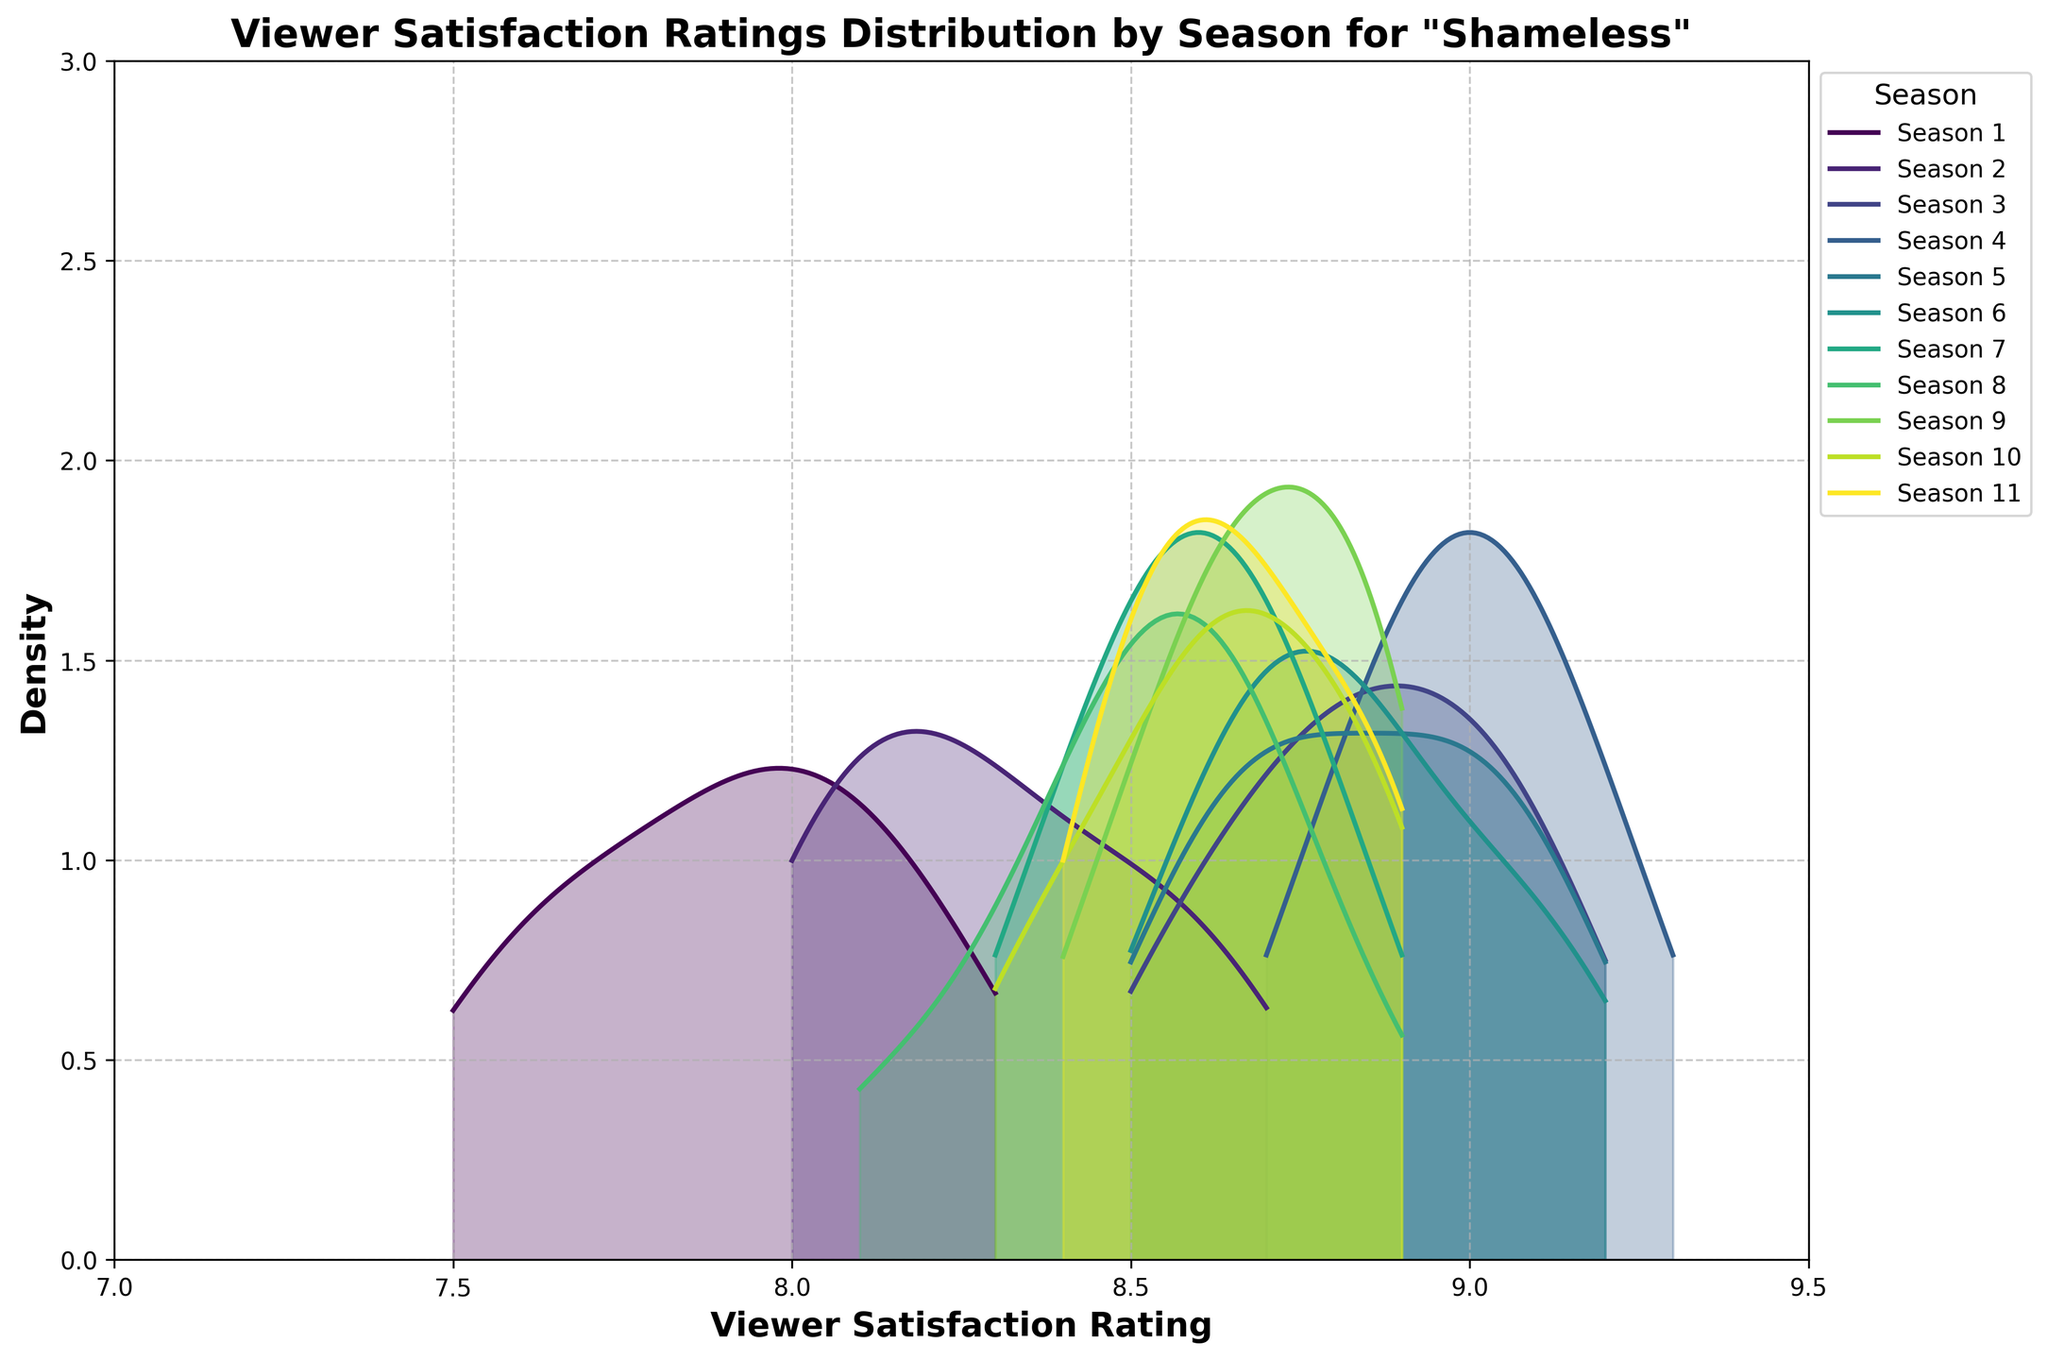Which season shows the highest peak in the density distribution? The highest peak in a density plot corresponds to the highest density of viewer satisfaction ratings. By visually inspecting the density curves, Season 3 shows the highest peak.
Answer: Season 3 What is the range of viewer satisfaction ratings plotted on the x-axis? The x-axis range is defined by the minimum and maximum viewer satisfaction ratings shown on the plot. The plot spans from 7 to 9.5.
Answer: 7 to 9.5 Which seasons have overlapping density curves around a rating of 8.9? To determine overlapping density curves at a rating of 8.9, examine the curves visually at this x-axis value. Seasons 6, 8, 9, 10, and 11 have densities around this point.
Answer: Seasons 6, 8, 9, 10, and 11 Are there any seasons where the viewer satisfaction ratings are more spread out compared to others? Spread out ratings are indicated by wider density curves. Season 1 shows a wider spread compared to the more peaked distributions of other seasons.
Answer: Season 1 Which season has the narrowest concentration of viewer satisfaction ratings? A narrow concentration is indicated by a sharp, peaked density curve. Season 3 shows the narrowest concentration with a sharp peak around 9.0.
Answer: Season 3 How does the density distribution of Season 7 compare to that of Season 11 around the rating of 8.7? Comparing the density values visually around 8.7, both seasons have a density curve passing through 8.7, but Season 7 appears slightly broader whereas Season 11 seems more concentrated.
Answer: Season 7 is broader, Season 11 is more concentrated Identify a season with a bimodal distribution, if any. A bimodal distribution would have two peaks in its density curve. Season 1 exhibits a slight bimodality with two noticeable peaks around 7.7 and 8.2.
Answer: Season 1 Which seasons show a density peak above 9.0? To find peaks above 9.0, look for density curves with significant values on or after 9.0. Seasons 3, 4, and 5 show peaks just above 9.0.
Answer: Seasons 3, 4, and 5 